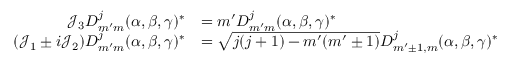<formula> <loc_0><loc_0><loc_500><loc_500>{ \begin{array} { r l } { { \mathcal { J } } _ { 3 } D _ { m ^ { \prime } m } ^ { j } ( \alpha , \beta , \gamma ) ^ { * } } & { = m ^ { \prime } D _ { m ^ { \prime } m } ^ { j } ( \alpha , \beta , \gamma ) ^ { * } } \\ { ( { \mathcal { J } } _ { 1 } \pm i { \mathcal { J } } _ { 2 } ) D _ { m ^ { \prime } m } ^ { j } ( \alpha , \beta , \gamma ) ^ { * } } & { = { \sqrt { j ( j + 1 ) - m ^ { \prime } ( m ^ { \prime } \pm 1 ) } } D _ { m ^ { \prime } \pm 1 , m } ^ { j } ( \alpha , \beta , \gamma ) ^ { * } } \end{array} }</formula> 